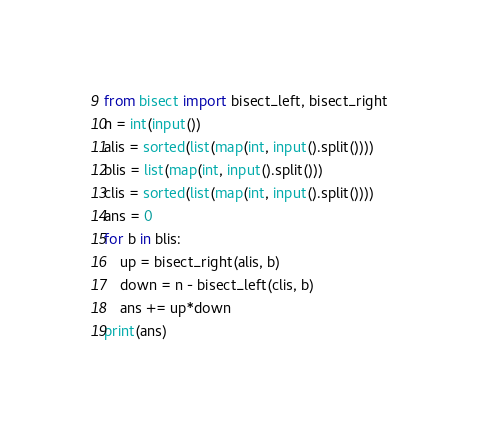Convert code to text. <code><loc_0><loc_0><loc_500><loc_500><_Python_>from bisect import bisect_left, bisect_right
n = int(input())
alis = sorted(list(map(int, input().split())))
blis = list(map(int, input().split()))
clis = sorted(list(map(int, input().split())))
ans = 0
for b in blis:
    up = bisect_right(alis, b)
    down = n - bisect_left(clis, b)
    ans += up*down
print(ans)</code> 